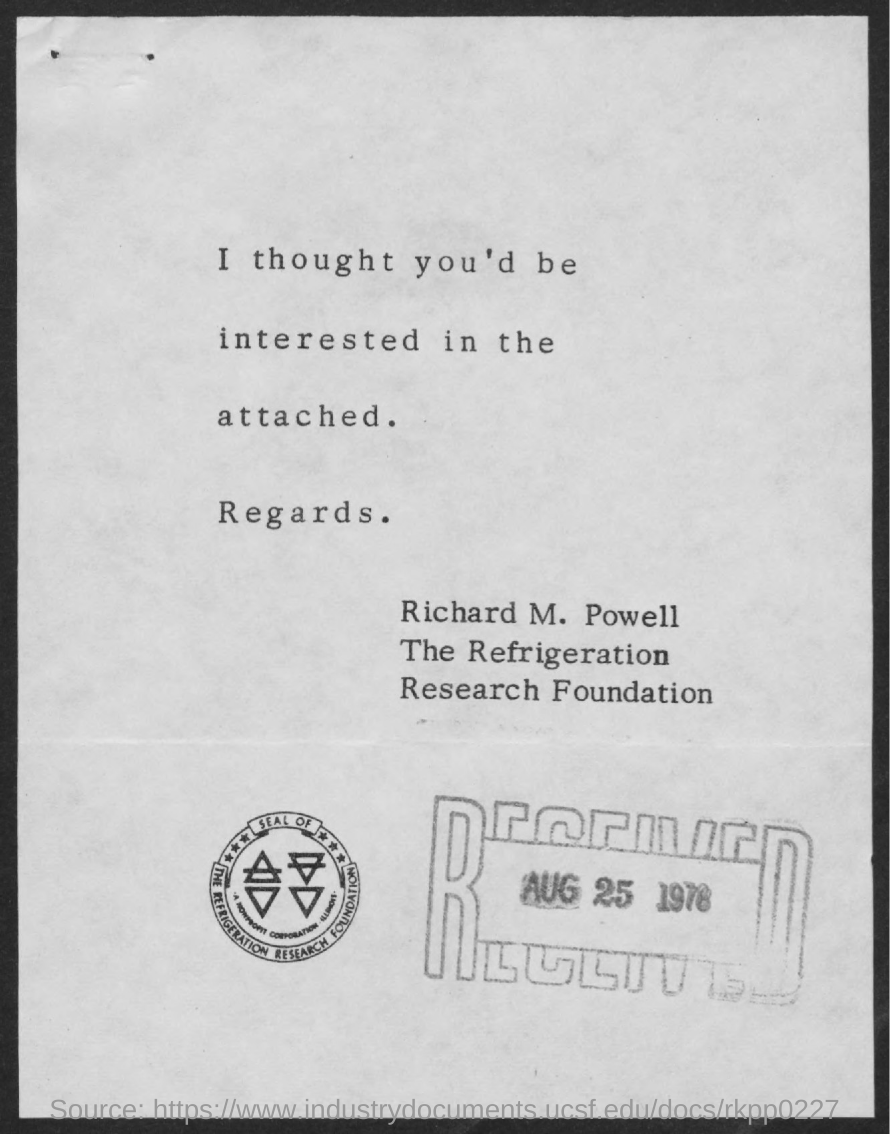Mention a couple of crucial points in this snapshot. The date on the stamp is August 25, 1976. 